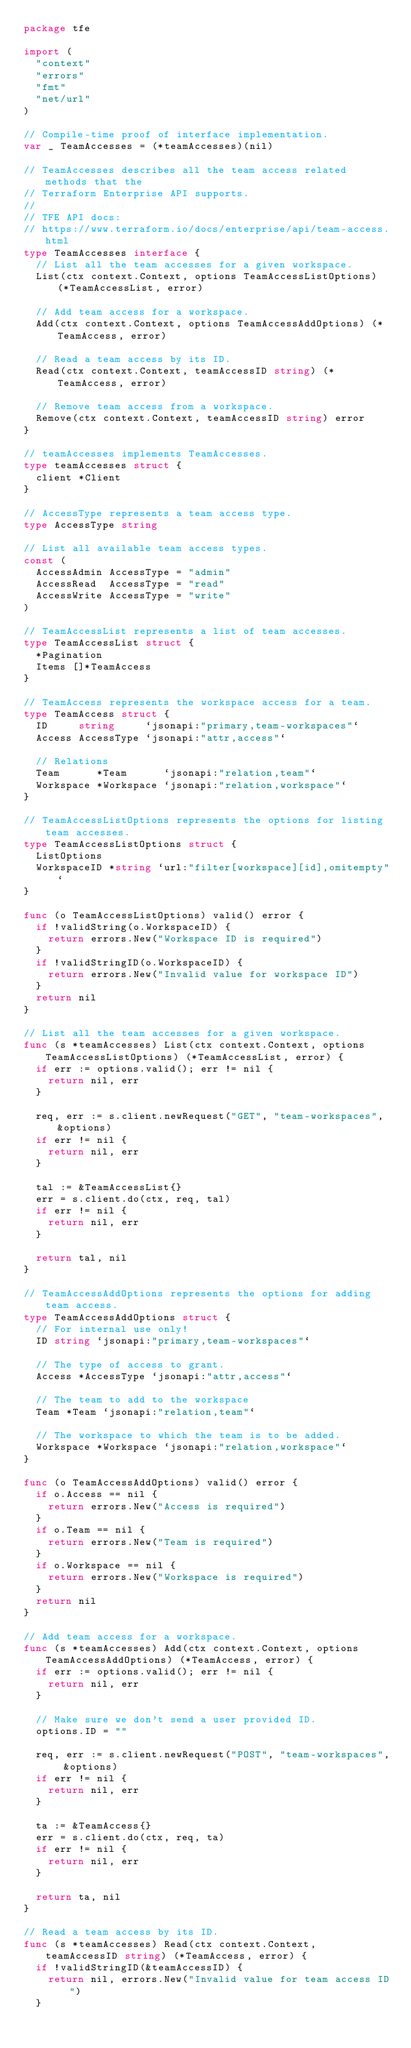Convert code to text. <code><loc_0><loc_0><loc_500><loc_500><_Go_>package tfe

import (
	"context"
	"errors"
	"fmt"
	"net/url"
)

// Compile-time proof of interface implementation.
var _ TeamAccesses = (*teamAccesses)(nil)

// TeamAccesses describes all the team access related methods that the
// Terraform Enterprise API supports.
//
// TFE API docs:
// https://www.terraform.io/docs/enterprise/api/team-access.html
type TeamAccesses interface {
	// List all the team accesses for a given workspace.
	List(ctx context.Context, options TeamAccessListOptions) (*TeamAccessList, error)

	// Add team access for a workspace.
	Add(ctx context.Context, options TeamAccessAddOptions) (*TeamAccess, error)

	// Read a team access by its ID.
	Read(ctx context.Context, teamAccessID string) (*TeamAccess, error)

	// Remove team access from a workspace.
	Remove(ctx context.Context, teamAccessID string) error
}

// teamAccesses implements TeamAccesses.
type teamAccesses struct {
	client *Client
}

// AccessType represents a team access type.
type AccessType string

// List all available team access types.
const (
	AccessAdmin AccessType = "admin"
	AccessRead  AccessType = "read"
	AccessWrite AccessType = "write"
)

// TeamAccessList represents a list of team accesses.
type TeamAccessList struct {
	*Pagination
	Items []*TeamAccess
}

// TeamAccess represents the workspace access for a team.
type TeamAccess struct {
	ID     string     `jsonapi:"primary,team-workspaces"`
	Access AccessType `jsonapi:"attr,access"`

	// Relations
	Team      *Team      `jsonapi:"relation,team"`
	Workspace *Workspace `jsonapi:"relation,workspace"`
}

// TeamAccessListOptions represents the options for listing team accesses.
type TeamAccessListOptions struct {
	ListOptions
	WorkspaceID *string `url:"filter[workspace][id],omitempty"`
}

func (o TeamAccessListOptions) valid() error {
	if !validString(o.WorkspaceID) {
		return errors.New("Workspace ID is required")
	}
	if !validStringID(o.WorkspaceID) {
		return errors.New("Invalid value for workspace ID")
	}
	return nil
}

// List all the team accesses for a given workspace.
func (s *teamAccesses) List(ctx context.Context, options TeamAccessListOptions) (*TeamAccessList, error) {
	if err := options.valid(); err != nil {
		return nil, err
	}

	req, err := s.client.newRequest("GET", "team-workspaces", &options)
	if err != nil {
		return nil, err
	}

	tal := &TeamAccessList{}
	err = s.client.do(ctx, req, tal)
	if err != nil {
		return nil, err
	}

	return tal, nil
}

// TeamAccessAddOptions represents the options for adding team access.
type TeamAccessAddOptions struct {
	// For internal use only!
	ID string `jsonapi:"primary,team-workspaces"`

	// The type of access to grant.
	Access *AccessType `jsonapi:"attr,access"`

	// The team to add to the workspace
	Team *Team `jsonapi:"relation,team"`

	// The workspace to which the team is to be added.
	Workspace *Workspace `jsonapi:"relation,workspace"`
}

func (o TeamAccessAddOptions) valid() error {
	if o.Access == nil {
		return errors.New("Access is required")
	}
	if o.Team == nil {
		return errors.New("Team is required")
	}
	if o.Workspace == nil {
		return errors.New("Workspace is required")
	}
	return nil
}

// Add team access for a workspace.
func (s *teamAccesses) Add(ctx context.Context, options TeamAccessAddOptions) (*TeamAccess, error) {
	if err := options.valid(); err != nil {
		return nil, err
	}

	// Make sure we don't send a user provided ID.
	options.ID = ""

	req, err := s.client.newRequest("POST", "team-workspaces", &options)
	if err != nil {
		return nil, err
	}

	ta := &TeamAccess{}
	err = s.client.do(ctx, req, ta)
	if err != nil {
		return nil, err
	}

	return ta, nil
}

// Read a team access by its ID.
func (s *teamAccesses) Read(ctx context.Context, teamAccessID string) (*TeamAccess, error) {
	if !validStringID(&teamAccessID) {
		return nil, errors.New("Invalid value for team access ID")
	}
</code> 